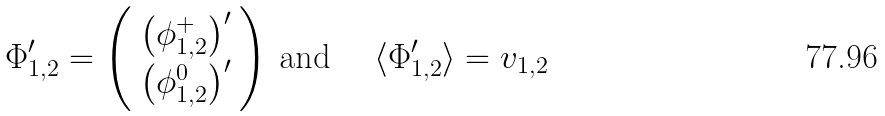<formula> <loc_0><loc_0><loc_500><loc_500>\Phi _ { 1 , 2 } ^ { \prime } = \left ( \begin{array} { c } \left ( \phi _ { 1 , 2 } ^ { + } \right ) ^ { \prime } \\ \left ( \phi _ { 1 , 2 } ^ { 0 } \right ) ^ { \prime } \end{array} \right ) \, \text {and\quad \ } \langle \Phi _ { 1 , 2 } ^ { \prime } \rangle = v _ { 1 , 2 }</formula> 